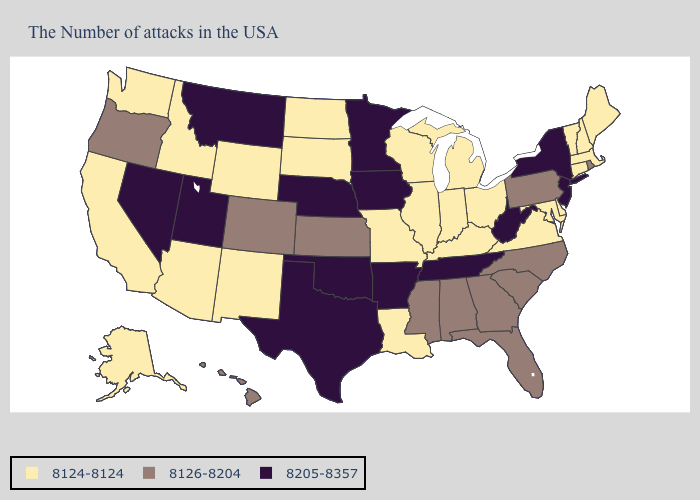What is the highest value in states that border Arizona?
Quick response, please. 8205-8357. Name the states that have a value in the range 8126-8204?
Give a very brief answer. Rhode Island, Pennsylvania, North Carolina, South Carolina, Florida, Georgia, Alabama, Mississippi, Kansas, Colorado, Oregon, Hawaii. Which states have the lowest value in the USA?
Concise answer only. Maine, Massachusetts, New Hampshire, Vermont, Connecticut, Delaware, Maryland, Virginia, Ohio, Michigan, Kentucky, Indiana, Wisconsin, Illinois, Louisiana, Missouri, South Dakota, North Dakota, Wyoming, New Mexico, Arizona, Idaho, California, Washington, Alaska. Name the states that have a value in the range 8124-8124?
Quick response, please. Maine, Massachusetts, New Hampshire, Vermont, Connecticut, Delaware, Maryland, Virginia, Ohio, Michigan, Kentucky, Indiana, Wisconsin, Illinois, Louisiana, Missouri, South Dakota, North Dakota, Wyoming, New Mexico, Arizona, Idaho, California, Washington, Alaska. Which states have the lowest value in the South?
Short answer required. Delaware, Maryland, Virginia, Kentucky, Louisiana. Does the map have missing data?
Write a very short answer. No. Does the first symbol in the legend represent the smallest category?
Answer briefly. Yes. What is the value of California?
Concise answer only. 8124-8124. What is the highest value in states that border Idaho?
Short answer required. 8205-8357. Name the states that have a value in the range 8124-8124?
Short answer required. Maine, Massachusetts, New Hampshire, Vermont, Connecticut, Delaware, Maryland, Virginia, Ohio, Michigan, Kentucky, Indiana, Wisconsin, Illinois, Louisiana, Missouri, South Dakota, North Dakota, Wyoming, New Mexico, Arizona, Idaho, California, Washington, Alaska. What is the value of Wisconsin?
Keep it brief. 8124-8124. What is the value of Washington?
Short answer required. 8124-8124. What is the value of Minnesota?
Short answer required. 8205-8357. What is the value of Washington?
Quick response, please. 8124-8124. Among the states that border Wisconsin , does Michigan have the highest value?
Keep it brief. No. 